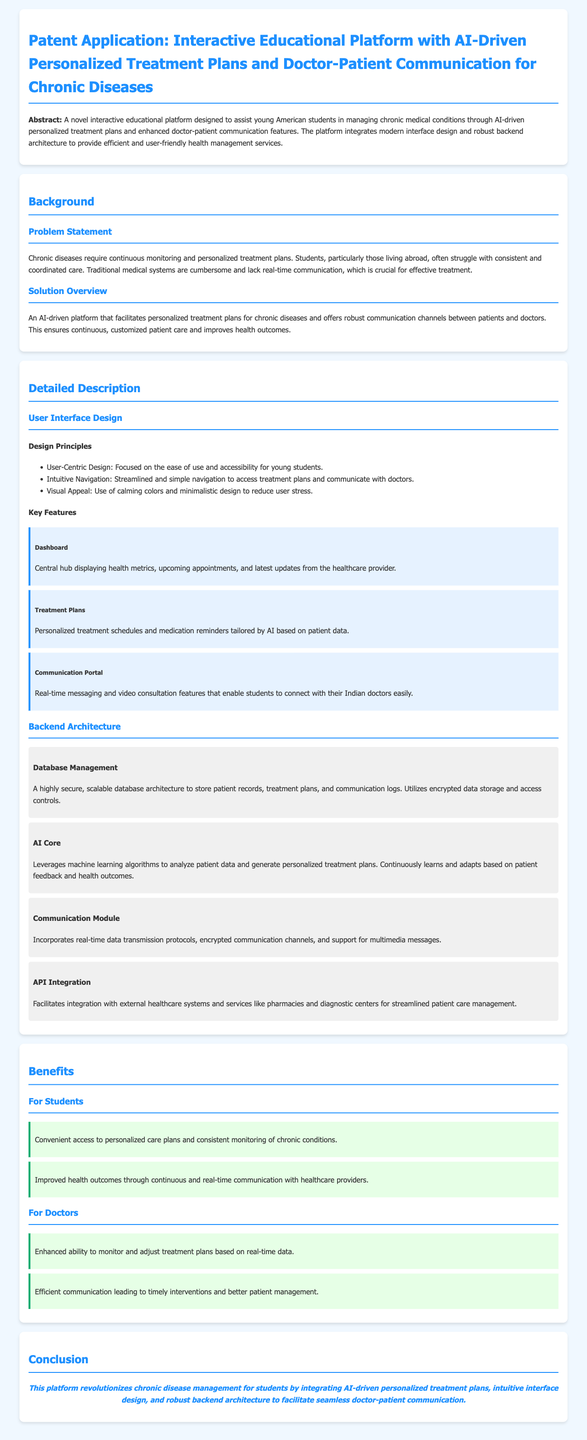What is the primary purpose of the platform? The platform is designed to assist young American students in managing chronic medical conditions.
Answer: manage chronic medical conditions What feature allows real-time communication with doctors? The communication portal enables students to connect with their doctors easily.
Answer: Communication Portal What is the main focus of the user interface design? The design is focused on ease of use and accessibility for young students.
Answer: User-Centric Design Which section details the data storage architecture? The database management section describes secure, scalable database architecture.
Answer: Database Management How does the AI core function in the platform? It leverages machine learning algorithms to analyze patient data and generate personalized treatment plans.
Answer: machine learning algorithms What are the benefits for doctors mentioned in the document? The benefits for doctors include enhanced monitoring and efficient communication.
Answer: Enhanced monitoring and efficient communication What design principle aims to reduce user stress? The use of calming colors and minimalistic design is intended to reduce user stress.
Answer: Visual Appeal How does the platform adapt treatment plans? It continuously learns and adapts based on patient feedback and health outcomes.
Answer: patient feedback and health outcomes What is the conclusion of the patent application? The conclusion summarizes the platform's innovations in chronic disease management.
Answer: revolutionizes chronic disease management 